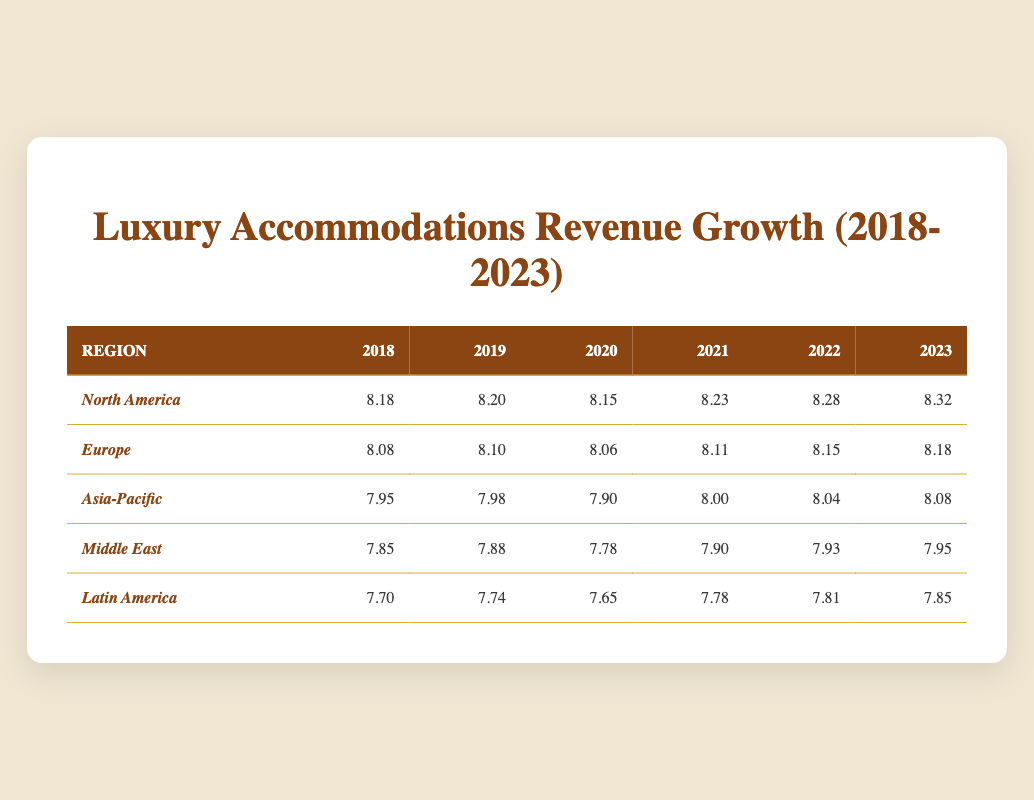What was the revenue growth for North America in 2021? The table shows that in 2021, the revenue growth for North America was logged as 8.23.
Answer: 8.23 Which region had the highest logarithmic revenue growth value in 2023? In the table for 2023, North America shows the highest value of 8.32.
Answer: North America Calculate the average logarithmic revenue growth for Latin America from 2018 to 2023. The values for Latin America from 2018 to 2023 are 7.70, 7.74, 7.65, 7.78, 7.81, and 7.85. Summing these gives 7.70 + 7.74 + 7.65 + 7.78 + 7.81 + 7.85 = 46.53. Dividing by 6 gives an average of 46.53 / 6 = 7.755.
Answer: 7.755 Did Europe experience any decrease in logarithmic revenue growth during the years from 2018 to 2023? By comparing the values for Europe, (8.08, 8.10, 8.06, 8.11, 8.15, 8.18), there is one decrease in 2020 (from 8.10 to 8.06). Thus, the answer is yes.
Answer: Yes Which region showed the most consistent growth in logarithmic revenue over the years? Analyzing the values, North America consistently increased every year from 8.18 (2018) to 8.32 (2023), showing no decreases, while other regions had fluctuations.
Answer: North America 